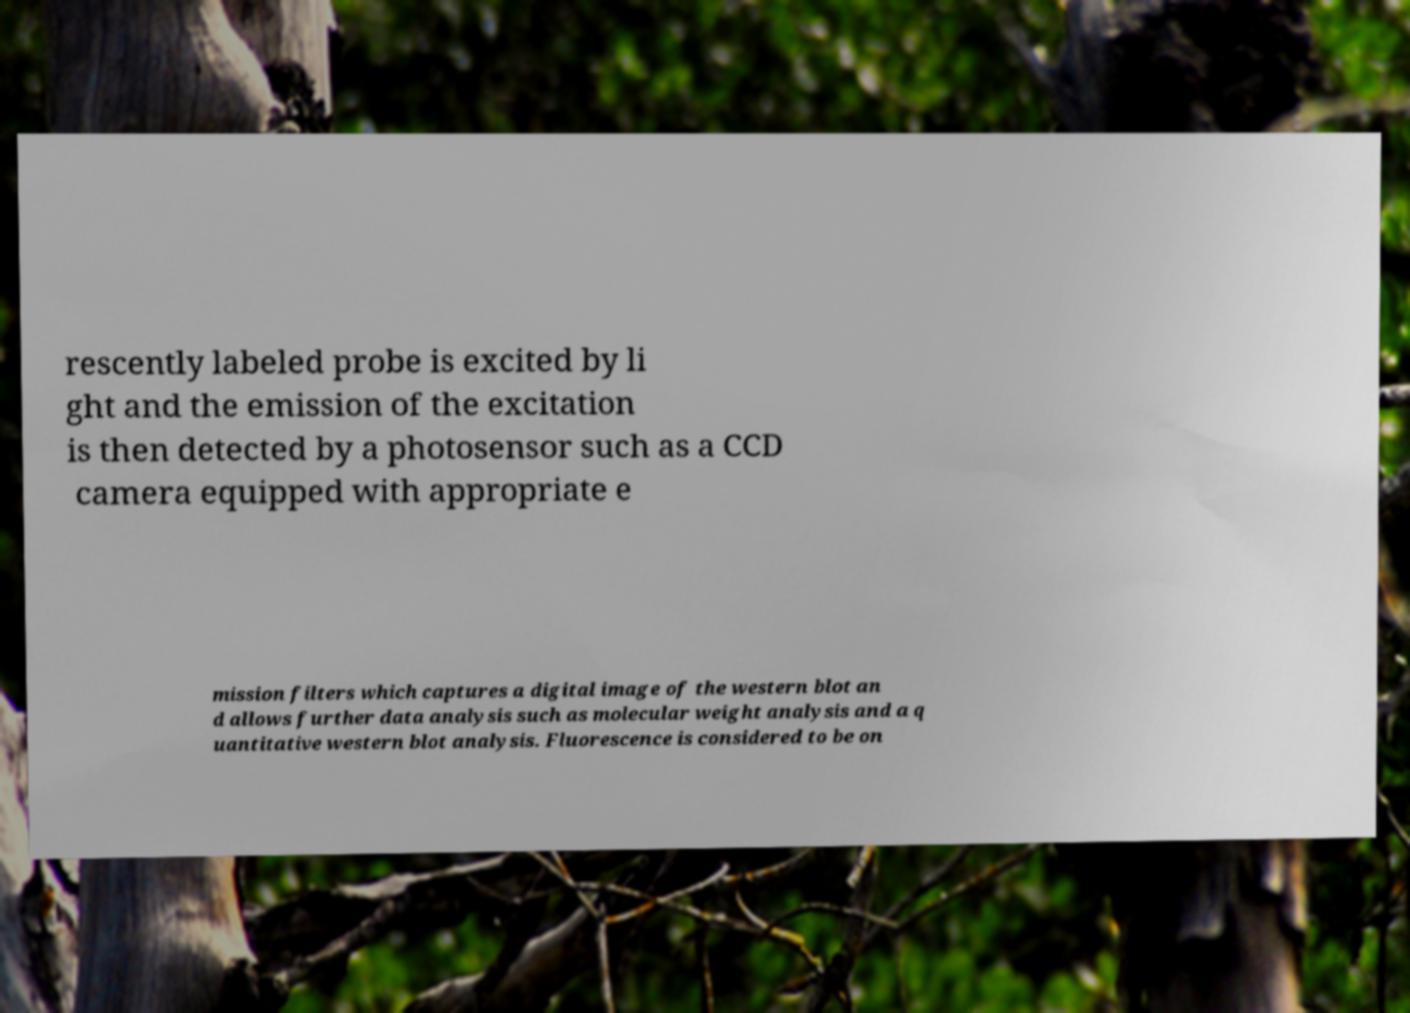Please read and relay the text visible in this image. What does it say? rescently labeled probe is excited by li ght and the emission of the excitation is then detected by a photosensor such as a CCD camera equipped with appropriate e mission filters which captures a digital image of the western blot an d allows further data analysis such as molecular weight analysis and a q uantitative western blot analysis. Fluorescence is considered to be on 